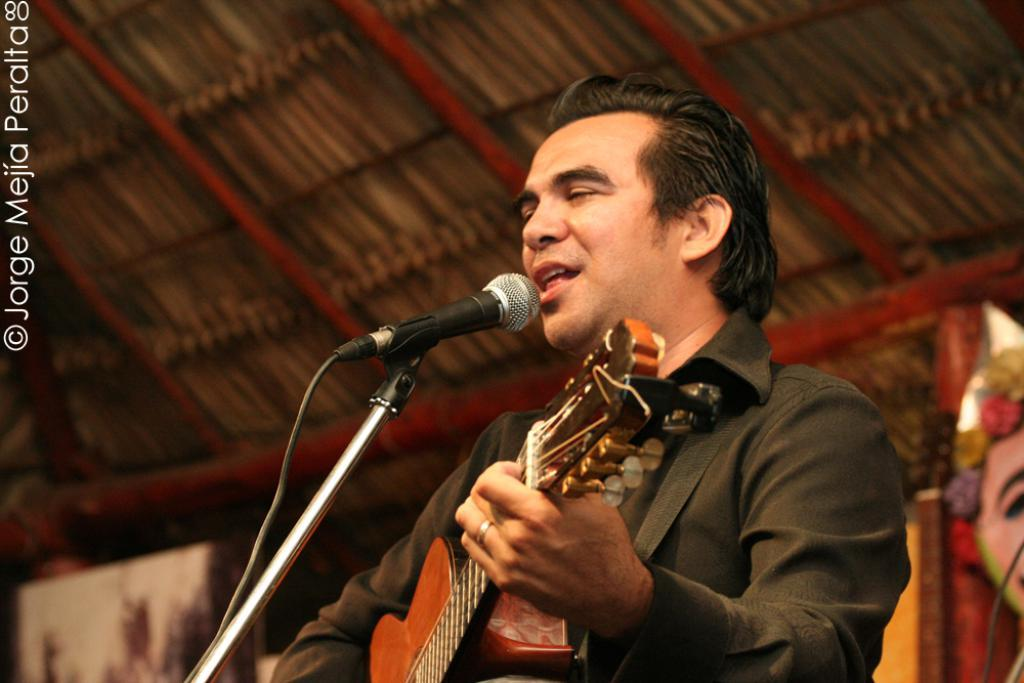What is the person holding in the image? The person is holding a guitar. What is the person doing while holding the guitar? The person is singing a song. What color jacket is the person wearing? The person is wearing a black color jacket. What can be seen in the background of the image? There is a tent and a poster in the background of the image. What type of leather is used to make the scent in the image? There is no leather or scent present in the image. 